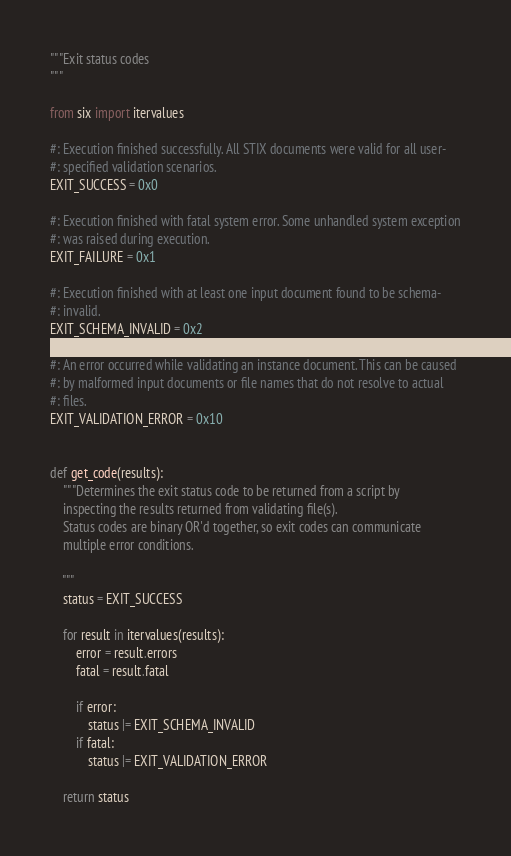<code> <loc_0><loc_0><loc_500><loc_500><_Python_>"""Exit status codes
"""

from six import itervalues

#: Execution finished successfully. All STIX documents were valid for all user-
#: specified validation scenarios.
EXIT_SUCCESS = 0x0

#: Execution finished with fatal system error. Some unhandled system exception
#: was raised during execution.
EXIT_FAILURE = 0x1

#: Execution finished with at least one input document found to be schema-
#: invalid.
EXIT_SCHEMA_INVALID = 0x2

#: An error occurred while validating an instance document. This can be caused
#: by malformed input documents or file names that do not resolve to actual
#: files.
EXIT_VALIDATION_ERROR = 0x10


def get_code(results):
    """Determines the exit status code to be returned from a script by
    inspecting the results returned from validating file(s).
    Status codes are binary OR'd together, so exit codes can communicate
    multiple error conditions.

    """
    status = EXIT_SUCCESS

    for result in itervalues(results):
        error = result.errors
        fatal = result.fatal

        if error:
            status |= EXIT_SCHEMA_INVALID
        if fatal:
            status |= EXIT_VALIDATION_ERROR

    return status
</code> 